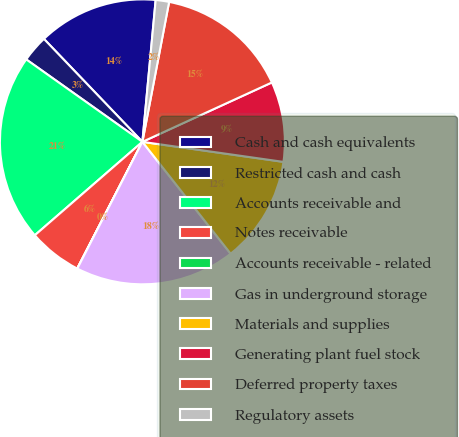<chart> <loc_0><loc_0><loc_500><loc_500><pie_chart><fcel>Cash and cash equivalents<fcel>Restricted cash and cash<fcel>Accounts receivable and<fcel>Notes receivable<fcel>Accounts receivable - related<fcel>Gas in underground storage<fcel>Materials and supplies<fcel>Generating plant fuel stock<fcel>Deferred property taxes<fcel>Regulatory assets<nl><fcel>13.63%<fcel>3.03%<fcel>21.2%<fcel>6.06%<fcel>0.01%<fcel>18.18%<fcel>12.12%<fcel>9.09%<fcel>15.15%<fcel>1.52%<nl></chart> 